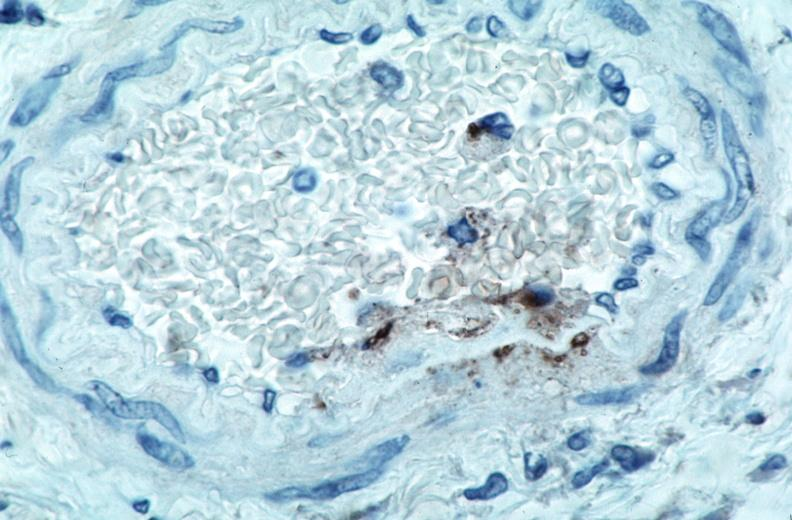what is vasculitis , rocky mountain spotted?
Answer the question using a single word or phrase. Fever immunoperoxidase staining vessels for rickettsia rickettsii 